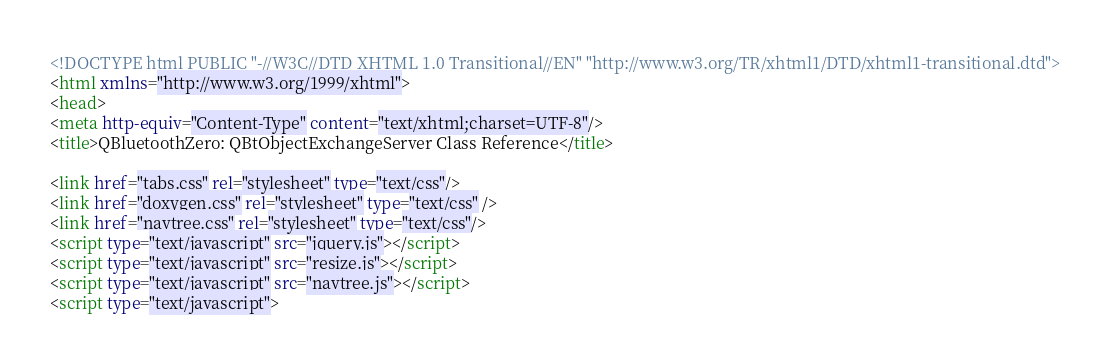Convert code to text. <code><loc_0><loc_0><loc_500><loc_500><_HTML_><!DOCTYPE html PUBLIC "-//W3C//DTD XHTML 1.0 Transitional//EN" "http://www.w3.org/TR/xhtml1/DTD/xhtml1-transitional.dtd">
<html xmlns="http://www.w3.org/1999/xhtml">
<head>
<meta http-equiv="Content-Type" content="text/xhtml;charset=UTF-8"/>
<title>QBluetoothZero: QBtObjectExchangeServer Class Reference</title>

<link href="tabs.css" rel="stylesheet" type="text/css"/>
<link href="doxygen.css" rel="stylesheet" type="text/css" />
<link href="navtree.css" rel="stylesheet" type="text/css"/>
<script type="text/javascript" src="jquery.js"></script>
<script type="text/javascript" src="resize.js"></script>
<script type="text/javascript" src="navtree.js"></script>
<script type="text/javascript"></code> 